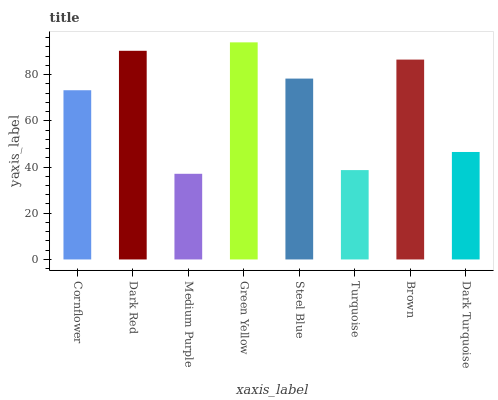Is Medium Purple the minimum?
Answer yes or no. Yes. Is Green Yellow the maximum?
Answer yes or no. Yes. Is Dark Red the minimum?
Answer yes or no. No. Is Dark Red the maximum?
Answer yes or no. No. Is Dark Red greater than Cornflower?
Answer yes or no. Yes. Is Cornflower less than Dark Red?
Answer yes or no. Yes. Is Cornflower greater than Dark Red?
Answer yes or no. No. Is Dark Red less than Cornflower?
Answer yes or no. No. Is Steel Blue the high median?
Answer yes or no. Yes. Is Cornflower the low median?
Answer yes or no. Yes. Is Cornflower the high median?
Answer yes or no. No. Is Medium Purple the low median?
Answer yes or no. No. 